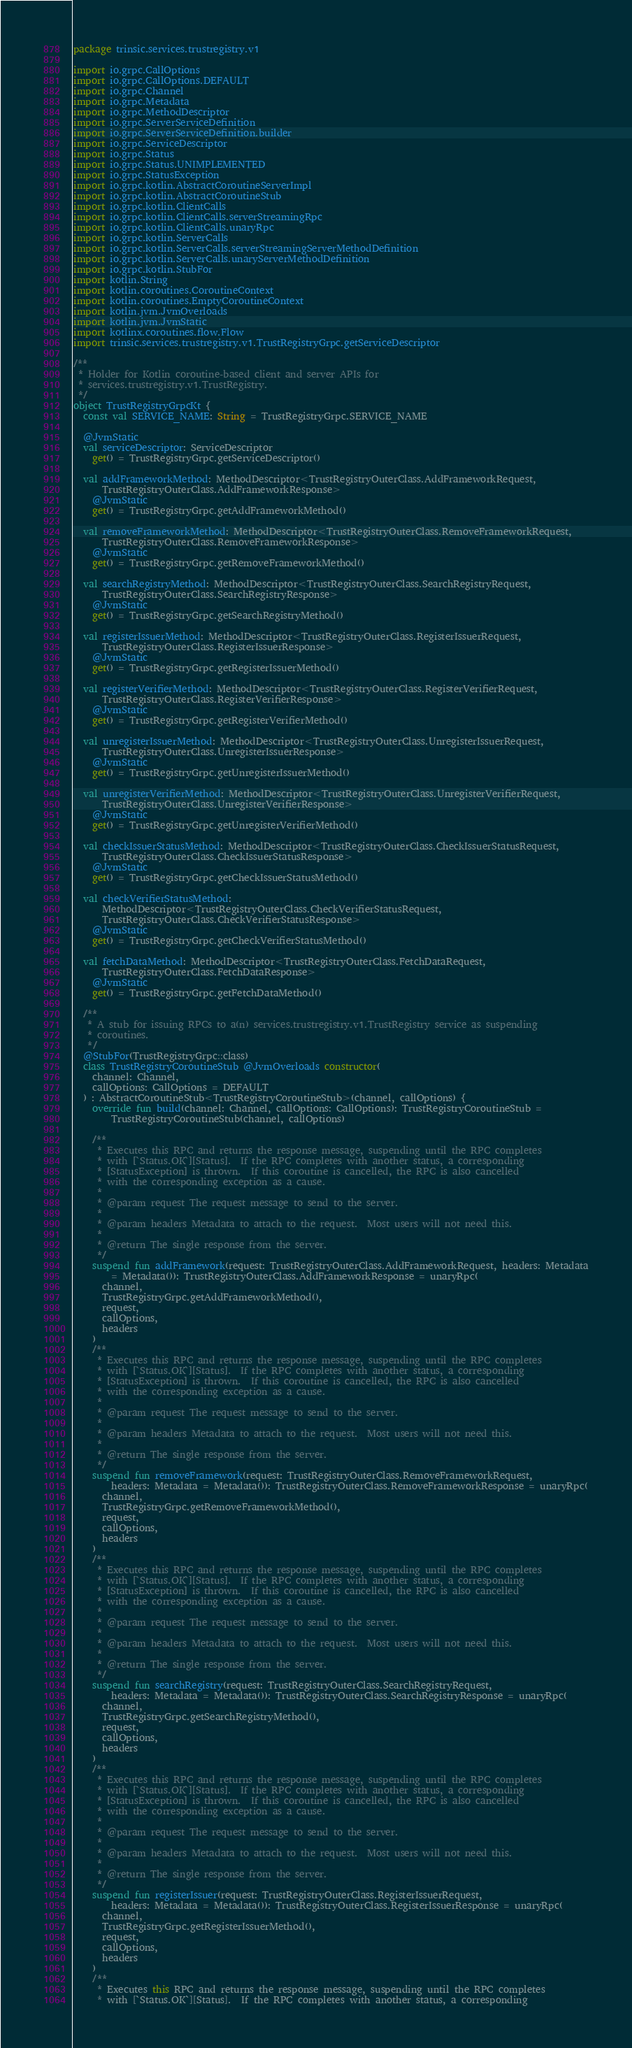Convert code to text. <code><loc_0><loc_0><loc_500><loc_500><_Kotlin_>package trinsic.services.trustregistry.v1

import io.grpc.CallOptions
import io.grpc.CallOptions.DEFAULT
import io.grpc.Channel
import io.grpc.Metadata
import io.grpc.MethodDescriptor
import io.grpc.ServerServiceDefinition
import io.grpc.ServerServiceDefinition.builder
import io.grpc.ServiceDescriptor
import io.grpc.Status
import io.grpc.Status.UNIMPLEMENTED
import io.grpc.StatusException
import io.grpc.kotlin.AbstractCoroutineServerImpl
import io.grpc.kotlin.AbstractCoroutineStub
import io.grpc.kotlin.ClientCalls
import io.grpc.kotlin.ClientCalls.serverStreamingRpc
import io.grpc.kotlin.ClientCalls.unaryRpc
import io.grpc.kotlin.ServerCalls
import io.grpc.kotlin.ServerCalls.serverStreamingServerMethodDefinition
import io.grpc.kotlin.ServerCalls.unaryServerMethodDefinition
import io.grpc.kotlin.StubFor
import kotlin.String
import kotlin.coroutines.CoroutineContext
import kotlin.coroutines.EmptyCoroutineContext
import kotlin.jvm.JvmOverloads
import kotlin.jvm.JvmStatic
import kotlinx.coroutines.flow.Flow
import trinsic.services.trustregistry.v1.TrustRegistryGrpc.getServiceDescriptor

/**
 * Holder for Kotlin coroutine-based client and server APIs for
 * services.trustregistry.v1.TrustRegistry.
 */
object TrustRegistryGrpcKt {
  const val SERVICE_NAME: String = TrustRegistryGrpc.SERVICE_NAME

  @JvmStatic
  val serviceDescriptor: ServiceDescriptor
    get() = TrustRegistryGrpc.getServiceDescriptor()

  val addFrameworkMethod: MethodDescriptor<TrustRegistryOuterClass.AddFrameworkRequest,
      TrustRegistryOuterClass.AddFrameworkResponse>
    @JvmStatic
    get() = TrustRegistryGrpc.getAddFrameworkMethod()

  val removeFrameworkMethod: MethodDescriptor<TrustRegistryOuterClass.RemoveFrameworkRequest,
      TrustRegistryOuterClass.RemoveFrameworkResponse>
    @JvmStatic
    get() = TrustRegistryGrpc.getRemoveFrameworkMethod()

  val searchRegistryMethod: MethodDescriptor<TrustRegistryOuterClass.SearchRegistryRequest,
      TrustRegistryOuterClass.SearchRegistryResponse>
    @JvmStatic
    get() = TrustRegistryGrpc.getSearchRegistryMethod()

  val registerIssuerMethod: MethodDescriptor<TrustRegistryOuterClass.RegisterIssuerRequest,
      TrustRegistryOuterClass.RegisterIssuerResponse>
    @JvmStatic
    get() = TrustRegistryGrpc.getRegisterIssuerMethod()

  val registerVerifierMethod: MethodDescriptor<TrustRegistryOuterClass.RegisterVerifierRequest,
      TrustRegistryOuterClass.RegisterVerifierResponse>
    @JvmStatic
    get() = TrustRegistryGrpc.getRegisterVerifierMethod()

  val unregisterIssuerMethod: MethodDescriptor<TrustRegistryOuterClass.UnregisterIssuerRequest,
      TrustRegistryOuterClass.UnregisterIssuerResponse>
    @JvmStatic
    get() = TrustRegistryGrpc.getUnregisterIssuerMethod()

  val unregisterVerifierMethod: MethodDescriptor<TrustRegistryOuterClass.UnregisterVerifierRequest,
      TrustRegistryOuterClass.UnregisterVerifierResponse>
    @JvmStatic
    get() = TrustRegistryGrpc.getUnregisterVerifierMethod()

  val checkIssuerStatusMethod: MethodDescriptor<TrustRegistryOuterClass.CheckIssuerStatusRequest,
      TrustRegistryOuterClass.CheckIssuerStatusResponse>
    @JvmStatic
    get() = TrustRegistryGrpc.getCheckIssuerStatusMethod()

  val checkVerifierStatusMethod:
      MethodDescriptor<TrustRegistryOuterClass.CheckVerifierStatusRequest,
      TrustRegistryOuterClass.CheckVerifierStatusResponse>
    @JvmStatic
    get() = TrustRegistryGrpc.getCheckVerifierStatusMethod()

  val fetchDataMethod: MethodDescriptor<TrustRegistryOuterClass.FetchDataRequest,
      TrustRegistryOuterClass.FetchDataResponse>
    @JvmStatic
    get() = TrustRegistryGrpc.getFetchDataMethod()

  /**
   * A stub for issuing RPCs to a(n) services.trustregistry.v1.TrustRegistry service as suspending
   * coroutines.
   */
  @StubFor(TrustRegistryGrpc::class)
  class TrustRegistryCoroutineStub @JvmOverloads constructor(
    channel: Channel,
    callOptions: CallOptions = DEFAULT
  ) : AbstractCoroutineStub<TrustRegistryCoroutineStub>(channel, callOptions) {
    override fun build(channel: Channel, callOptions: CallOptions): TrustRegistryCoroutineStub =
        TrustRegistryCoroutineStub(channel, callOptions)

    /**
     * Executes this RPC and returns the response message, suspending until the RPC completes
     * with [`Status.OK`][Status].  If the RPC completes with another status, a corresponding
     * [StatusException] is thrown.  If this coroutine is cancelled, the RPC is also cancelled
     * with the corresponding exception as a cause.
     *
     * @param request The request message to send to the server.
     *
     * @param headers Metadata to attach to the request.  Most users will not need this.
     *
     * @return The single response from the server.
     */
    suspend fun addFramework(request: TrustRegistryOuterClass.AddFrameworkRequest, headers: Metadata
        = Metadata()): TrustRegistryOuterClass.AddFrameworkResponse = unaryRpc(
      channel,
      TrustRegistryGrpc.getAddFrameworkMethod(),
      request,
      callOptions,
      headers
    )
    /**
     * Executes this RPC and returns the response message, suspending until the RPC completes
     * with [`Status.OK`][Status].  If the RPC completes with another status, a corresponding
     * [StatusException] is thrown.  If this coroutine is cancelled, the RPC is also cancelled
     * with the corresponding exception as a cause.
     *
     * @param request The request message to send to the server.
     *
     * @param headers Metadata to attach to the request.  Most users will not need this.
     *
     * @return The single response from the server.
     */
    suspend fun removeFramework(request: TrustRegistryOuterClass.RemoveFrameworkRequest,
        headers: Metadata = Metadata()): TrustRegistryOuterClass.RemoveFrameworkResponse = unaryRpc(
      channel,
      TrustRegistryGrpc.getRemoveFrameworkMethod(),
      request,
      callOptions,
      headers
    )
    /**
     * Executes this RPC and returns the response message, suspending until the RPC completes
     * with [`Status.OK`][Status].  If the RPC completes with another status, a corresponding
     * [StatusException] is thrown.  If this coroutine is cancelled, the RPC is also cancelled
     * with the corresponding exception as a cause.
     *
     * @param request The request message to send to the server.
     *
     * @param headers Metadata to attach to the request.  Most users will not need this.
     *
     * @return The single response from the server.
     */
    suspend fun searchRegistry(request: TrustRegistryOuterClass.SearchRegistryRequest,
        headers: Metadata = Metadata()): TrustRegistryOuterClass.SearchRegistryResponse = unaryRpc(
      channel,
      TrustRegistryGrpc.getSearchRegistryMethod(),
      request,
      callOptions,
      headers
    )
    /**
     * Executes this RPC and returns the response message, suspending until the RPC completes
     * with [`Status.OK`][Status].  If the RPC completes with another status, a corresponding
     * [StatusException] is thrown.  If this coroutine is cancelled, the RPC is also cancelled
     * with the corresponding exception as a cause.
     *
     * @param request The request message to send to the server.
     *
     * @param headers Metadata to attach to the request.  Most users will not need this.
     *
     * @return The single response from the server.
     */
    suspend fun registerIssuer(request: TrustRegistryOuterClass.RegisterIssuerRequest,
        headers: Metadata = Metadata()): TrustRegistryOuterClass.RegisterIssuerResponse = unaryRpc(
      channel,
      TrustRegistryGrpc.getRegisterIssuerMethod(),
      request,
      callOptions,
      headers
    )
    /**
     * Executes this RPC and returns the response message, suspending until the RPC completes
     * with [`Status.OK`][Status].  If the RPC completes with another status, a corresponding</code> 